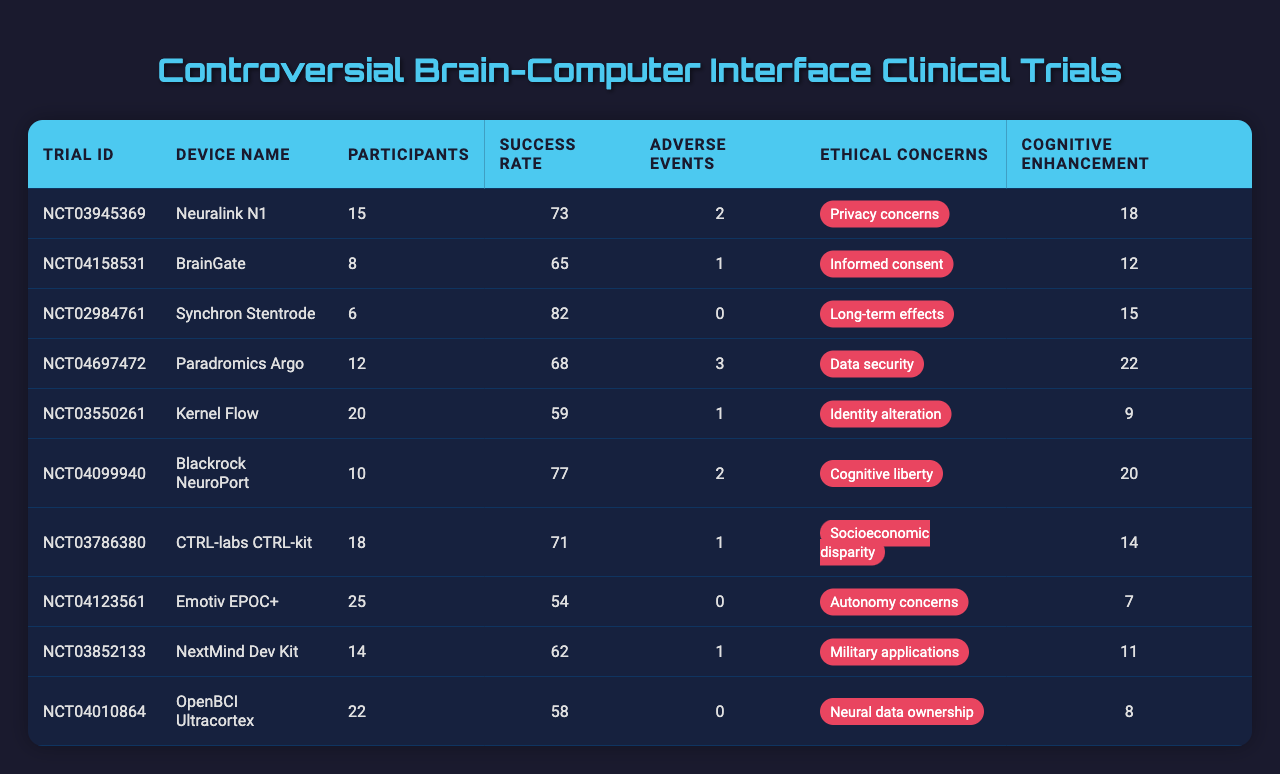What is the success rate of the Neuralink N1 trial? The success rate for the Neuralink N1 trial is mentioned directly in the table under the "Success Rate" column for that trial. It is listed as 73.
Answer: 73 How many participants were involved in the BrainGate trial? The “Participants” column for the BrainGate trial shows the number, which directly indicates that 8 participants were involved.
Answer: 8 Which device had the highest success rate? By comparing the "Success Rate" column, the Synchron Stentrode trial has the highest value at 82.
Answer: 82 What is the total number of adverse events reported across all trials? To find the total, I sum the numbers in the "Adverse Events" column: 2 + 1 + 0 + 3 + 1 + 2 + 1 + 0 + 1 + 0 = 11.
Answer: 11 Is there any trial with both cognitive enhancement and ethical concerns? Examining the columns, all trials have cognitive enhancement values and associated ethical concerns. Therefore, the answer is yes.
Answer: Yes Which device name corresponds to the greatest number of adverse events? By checking the "Adverse Events" column, the Paradromics Argo trial reported the most with 3 adverse events.
Answer: Paradromics Argo What is the average number of participants across all trials? To calculate the average, first sum the participants: 15 + 8 + 6 + 12 + 20 + 10 + 18 + 25 + 14 + 22 =  156. Since there are 10 trials, divide by 10: 156 / 10 = 15.6.
Answer: 15.6 How many devices have ethical concerns related to data security? The table shows that only one device, the Paradromics Argo, has "Data security" listed as its ethical concern.
Answer: 1 Which trial had the lowest success rate and how much was it? By reviewing the "Success Rate", the trial with the lowest success rate is Emotiv EPOC+ at 54.
Answer: Emotiv EPOC+, 54 Calculate the difference in the number of cognitive enhancement points between the trial with the highest and the lowest. From the "Cognitive Enhancement" column, the highest is the Paradromics Argo with 22 points and the lowest is the Emotiv EPOC+ with 7 points. The difference is 22 - 7 = 15.
Answer: 15 Are there more participants in trials with adverse events than in those without? Trials with adverse events have a total of: 15 + 8 + 6 + 12 + 20 + 10 + 18 + 25 + 14 + 22 (where the trials with adverse events are Neuralink N1, BrainGate, Paradromics Argo, Blackrock NeuroPort, CTRL-labs CTRL-kit, NextMind Dev Kit) = 156. The remaining trials without adverse events are: Synchron Stentrode (6), Kernel Flow (20), OpenBCI Ultracortex (22) = 48. Since 156 > 48, the answer is yes.
Answer: Yes 